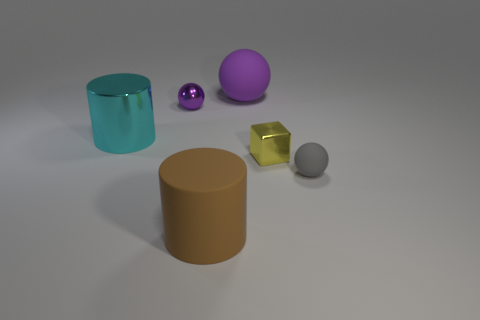Subtract all small balls. How many balls are left? 1 Subtract 3 spheres. How many spheres are left? 0 Add 1 large blue things. How many objects exist? 7 Subtract all purple balls. How many balls are left? 1 Subtract all yellow shiny things. Subtract all gray spheres. How many objects are left? 4 Add 1 big cylinders. How many big cylinders are left? 3 Add 4 yellow balls. How many yellow balls exist? 4 Subtract 1 gray balls. How many objects are left? 5 Subtract all blocks. How many objects are left? 5 Subtract all red cylinders. Subtract all brown spheres. How many cylinders are left? 2 